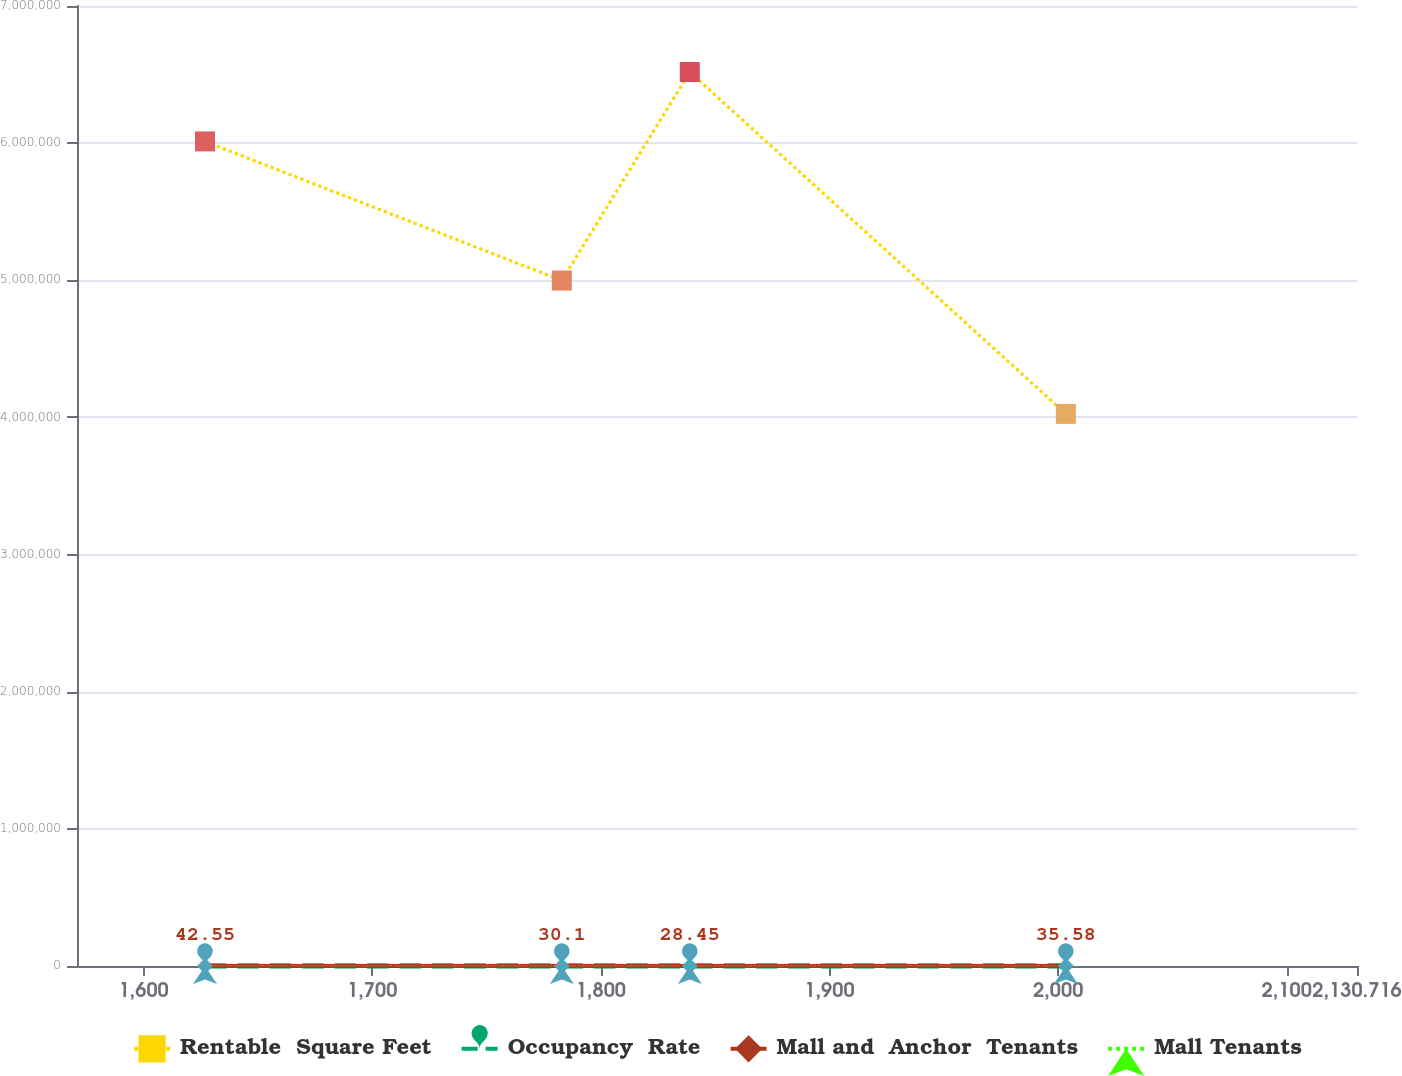Convert chart. <chart><loc_0><loc_0><loc_500><loc_500><line_chart><ecel><fcel>Rentable  Square Feet<fcel>Occupancy  Rate<fcel>Mall and  Anchor  Tenants<fcel>Mall Tenants<nl><fcel>1626.86<fcel>6.01259e+06<fcel>97.3<fcel>42.55<fcel>17.01<nl><fcel>1782.92<fcel>4.99809e+06<fcel>106.29<fcel>30.1<fcel>18.04<nl><fcel>1838.9<fcel>6.51854e+06<fcel>95.44<fcel>28.45<fcel>14.72<nl><fcel>2003.37<fcel>4.02565e+06<fcel>108.15<fcel>35.58<fcel>16.13<nl><fcel>2186.7<fcel>4.31213e+06<fcel>88.71<fcel>38.31<fcel>17.73<nl></chart> 